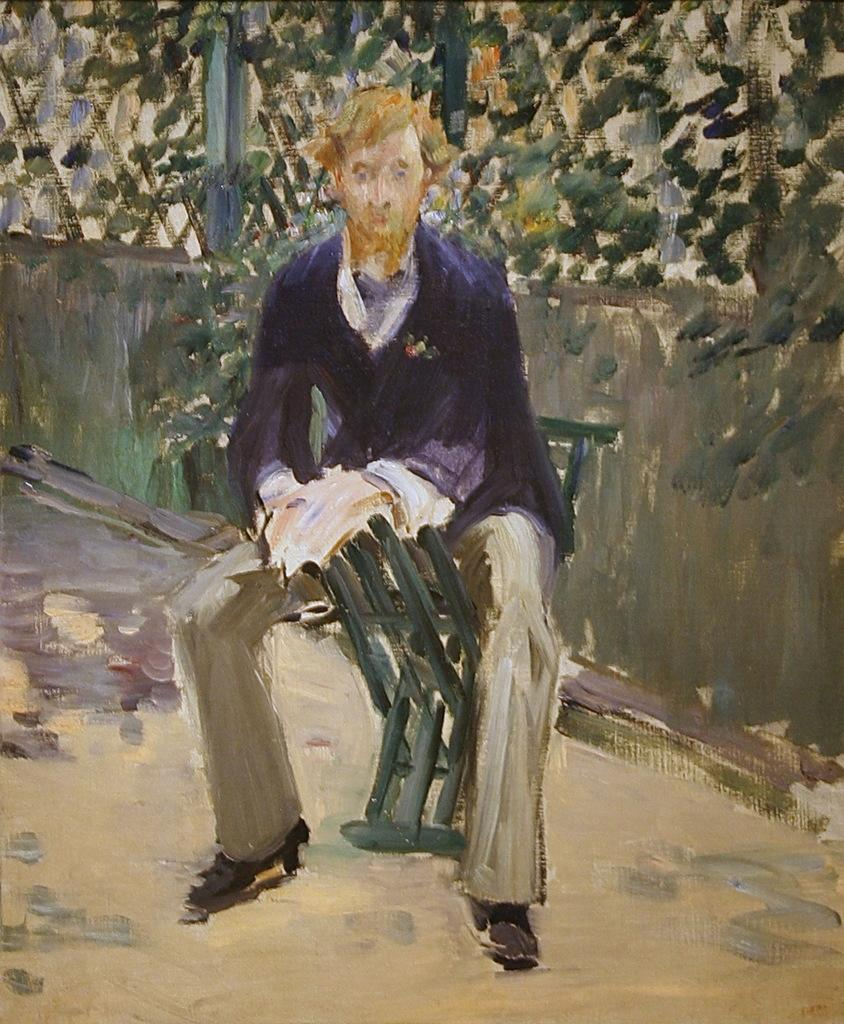What type of artwork is depicted in the image? The image is a painting. What is the person in the painting doing? The person is sitting on a chair in the painting. Where is the chair located in the painting? The chair is on the floor in the painting. What can be seen in the background of the painting? There is a wall visible in the background of the painting, and there are objects present in the background as well. How many toes are visible on the person's feet in the painting? There is no visible feet or toes in the painting; the person is sitting on a chair. 